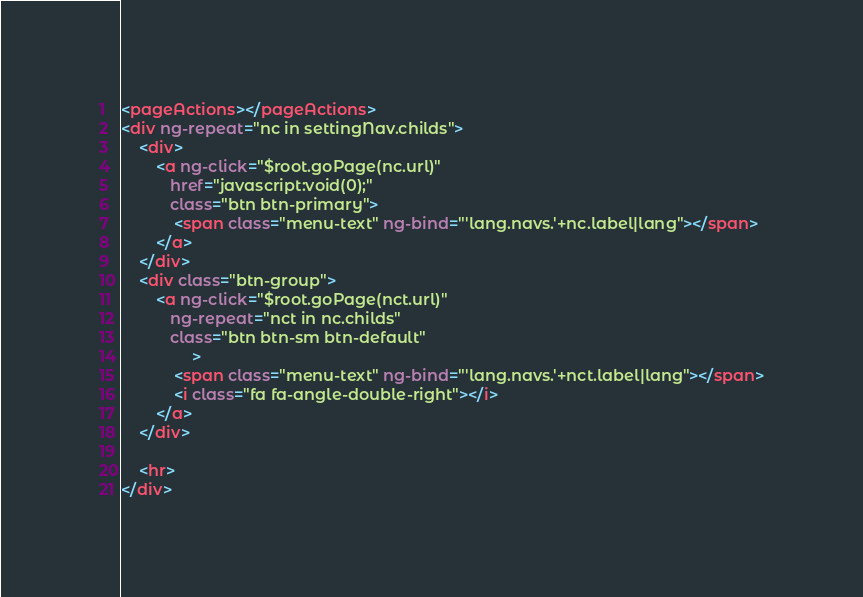<code> <loc_0><loc_0><loc_500><loc_500><_HTML_><pageActions></pageActions>
<div ng-repeat="nc in settingNav.childs">
    <div>
        <a ng-click="$root.goPage(nc.url)"
           href="javascript:void(0);"
           class="btn btn-primary">
            <span class="menu-text" ng-bind="'lang.navs.'+nc.label|lang"></span>
        </a>
    </div>
    <div class="btn-group">
        <a ng-click="$root.goPage(nct.url)"
           ng-repeat="nct in nc.childs"
           class="btn btn-sm btn-default"
                >
            <span class="menu-text" ng-bind="'lang.navs.'+nct.label|lang"></span>
            <i class="fa fa-angle-double-right"></i>
        </a>        
    </div>
    
    <hr>
</div></code> 